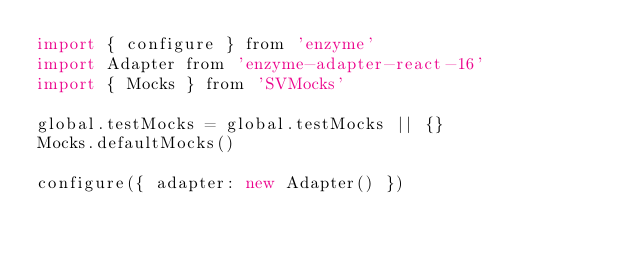Convert code to text. <code><loc_0><loc_0><loc_500><loc_500><_JavaScript_>import { configure } from 'enzyme'
import Adapter from 'enzyme-adapter-react-16'
import { Mocks } from 'SVMocks'

global.testMocks = global.testMocks || {}
Mocks.defaultMocks()

configure({ adapter: new Adapter() })
</code> 